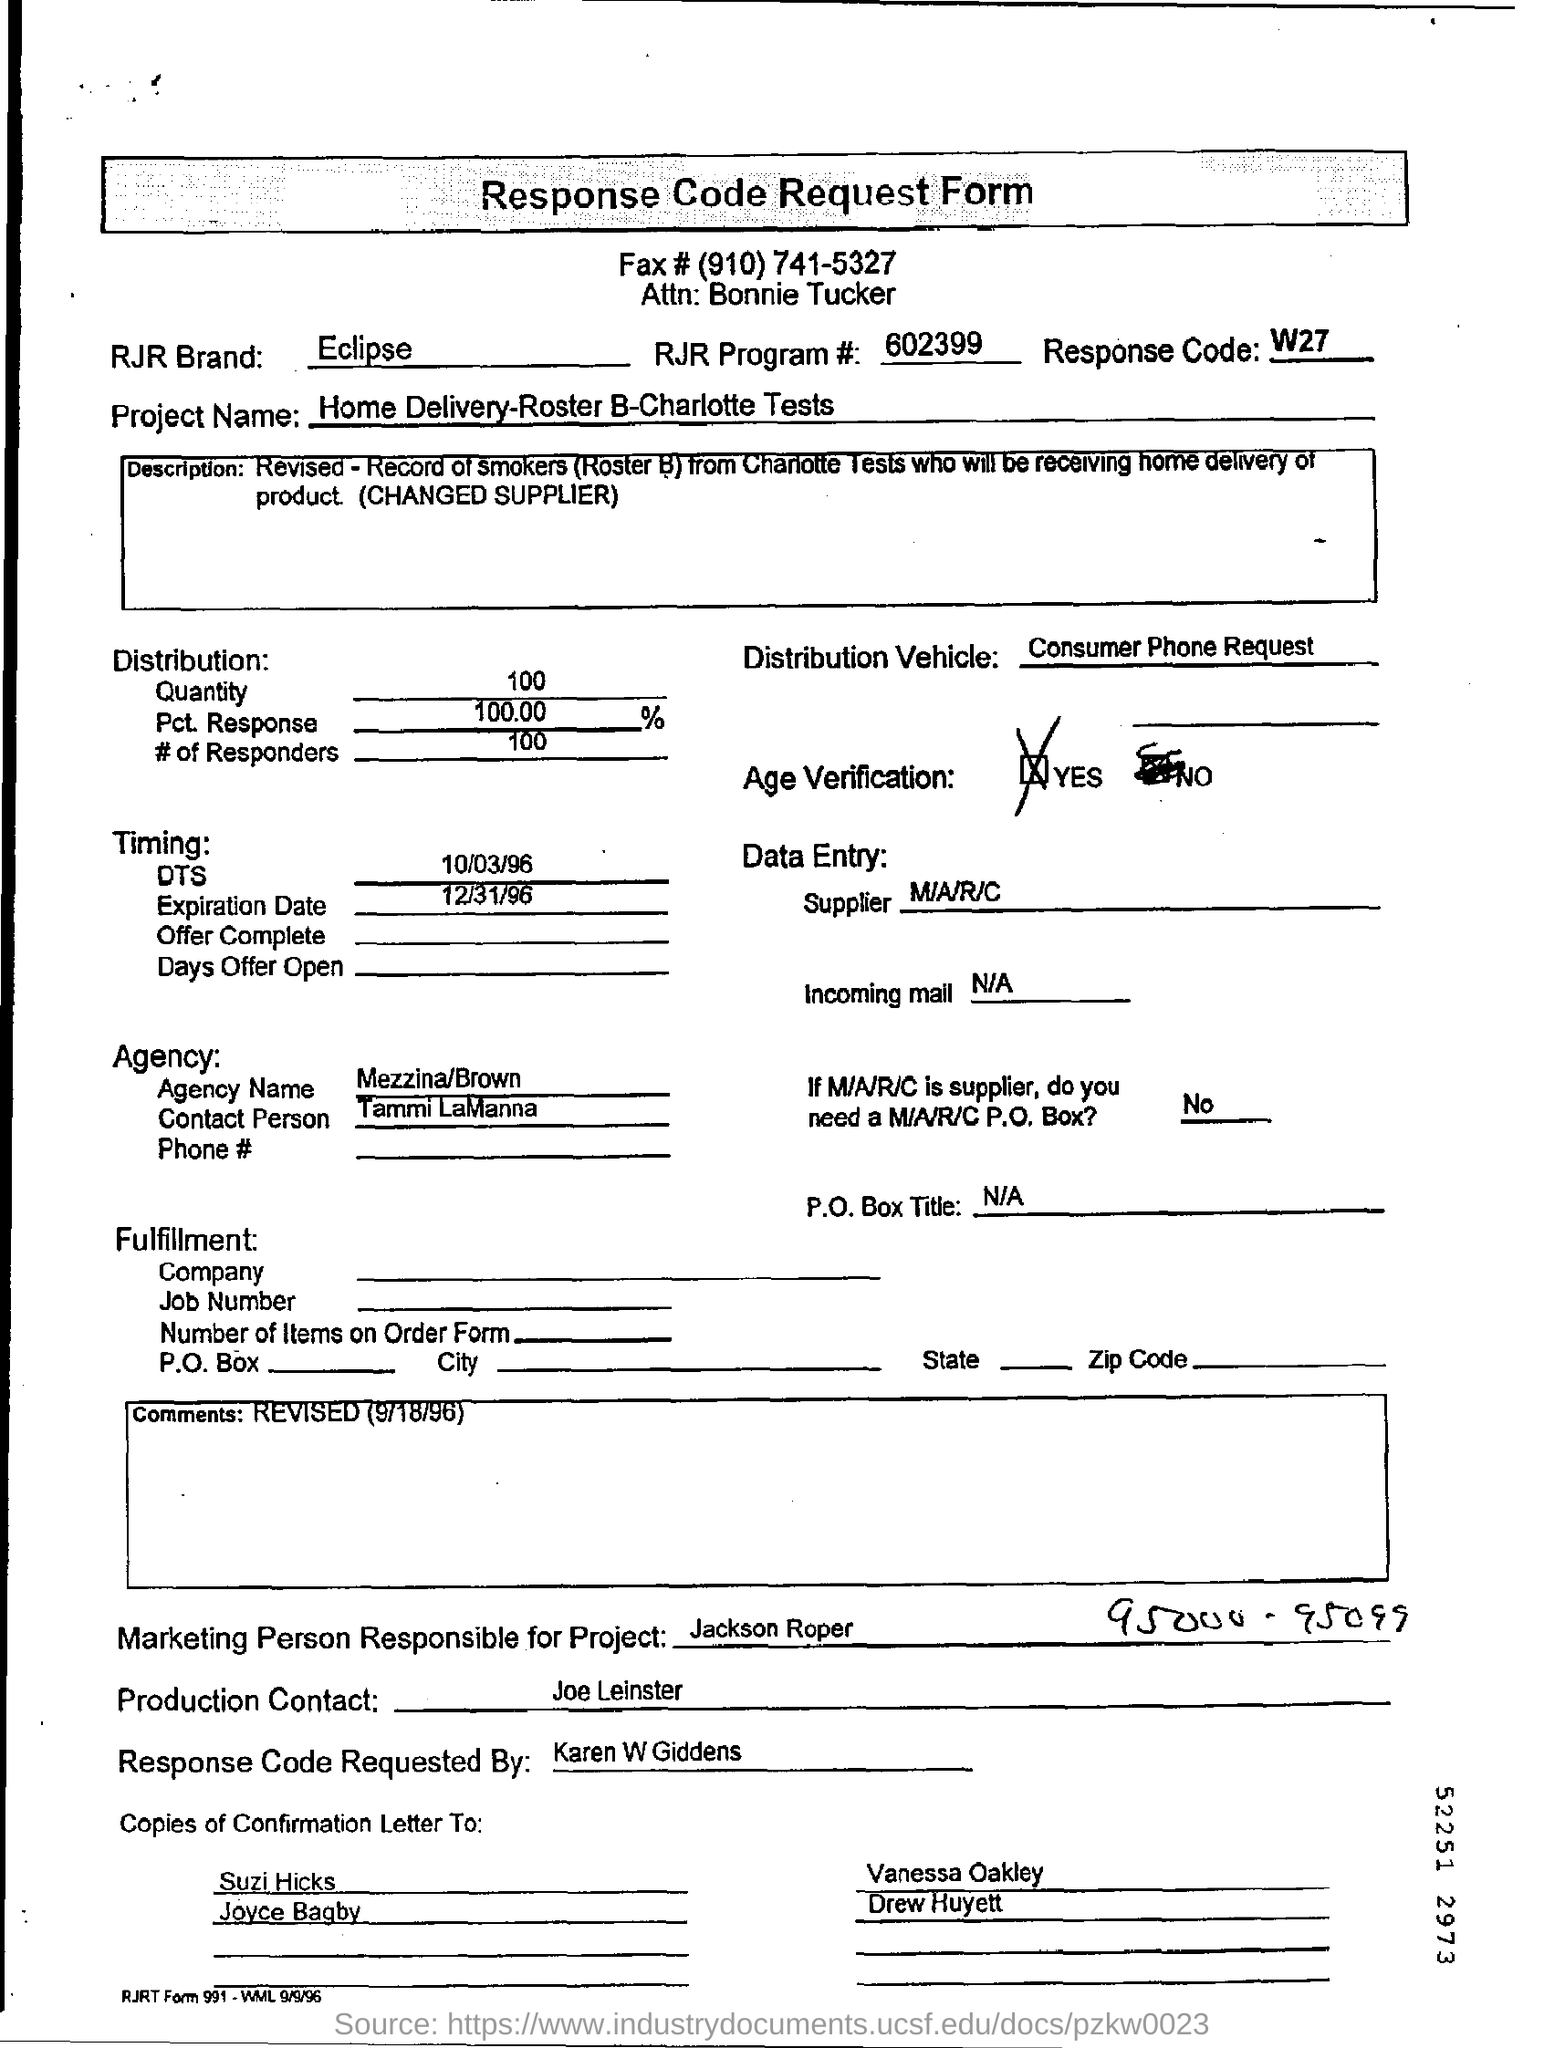Point out several critical features in this image. The distribution vehicle contains a request from a consumer for information about the products being distributed. The heading of the document is "Response Code Request Form. The request for the response code is made by Karen W Giddens. The RJR Brand is known for its Eclipse brand of cigarettes, which is a popular brand of cigarettes in the United States. 